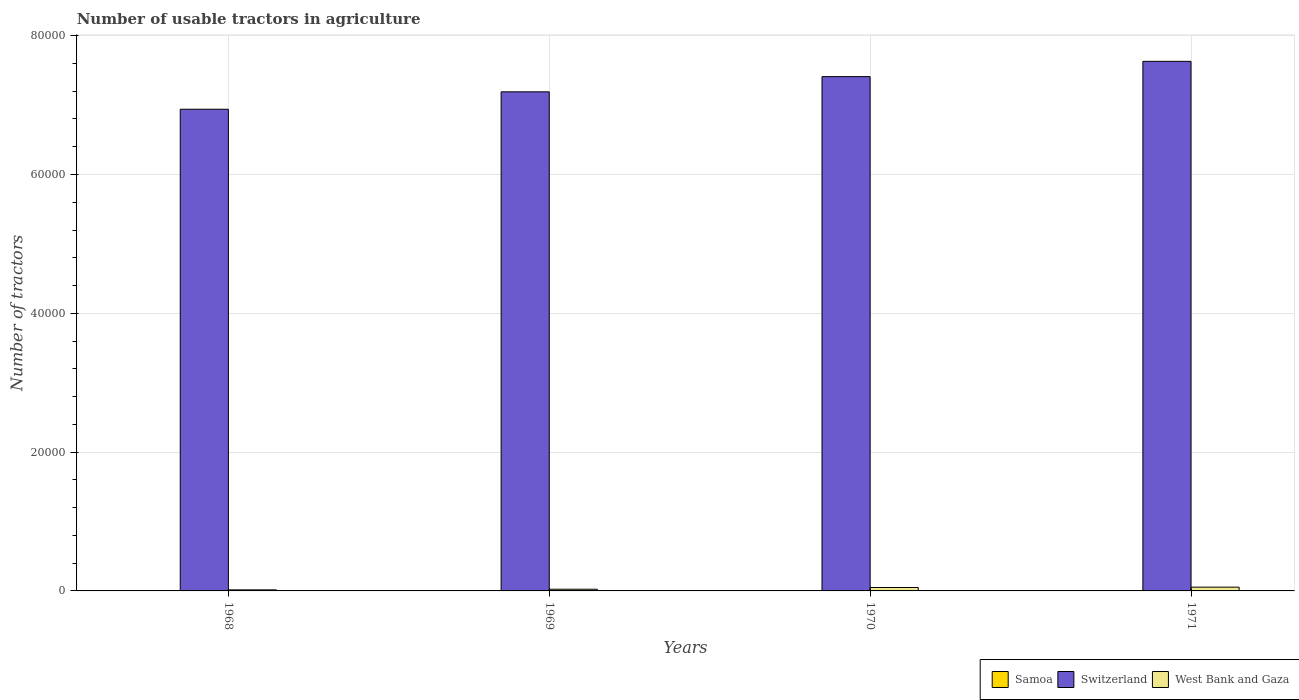How many different coloured bars are there?
Give a very brief answer. 3. How many groups of bars are there?
Offer a terse response. 4. How many bars are there on the 1st tick from the left?
Give a very brief answer. 3. In how many cases, is the number of bars for a given year not equal to the number of legend labels?
Your answer should be very brief. 0. What is the number of usable tractors in agriculture in Switzerland in 1968?
Give a very brief answer. 6.94e+04. Across all years, what is the maximum number of usable tractors in agriculture in Switzerland?
Your response must be concise. 7.63e+04. Across all years, what is the minimum number of usable tractors in agriculture in West Bank and Gaza?
Keep it short and to the point. 152. In which year was the number of usable tractors in agriculture in Switzerland maximum?
Your answer should be compact. 1971. In which year was the number of usable tractors in agriculture in Switzerland minimum?
Your answer should be compact. 1968. What is the total number of usable tractors in agriculture in Samoa in the graph?
Make the answer very short. 64. What is the difference between the number of usable tractors in agriculture in West Bank and Gaza in 1970 and that in 1971?
Provide a succinct answer. -53. What is the difference between the number of usable tractors in agriculture in Switzerland in 1968 and the number of usable tractors in agriculture in Samoa in 1971?
Offer a terse response. 6.94e+04. In the year 1970, what is the difference between the number of usable tractors in agriculture in West Bank and Gaza and number of usable tractors in agriculture in Samoa?
Make the answer very short. 476. In how many years, is the number of usable tractors in agriculture in Samoa greater than 40000?
Provide a short and direct response. 0. What is the ratio of the number of usable tractors in agriculture in Switzerland in 1970 to that in 1971?
Give a very brief answer. 0.97. What is the difference between the highest and the second highest number of usable tractors in agriculture in West Bank and Gaza?
Your answer should be very brief. 53. What does the 1st bar from the left in 1968 represents?
Give a very brief answer. Samoa. What does the 2nd bar from the right in 1971 represents?
Give a very brief answer. Switzerland. Is it the case that in every year, the sum of the number of usable tractors in agriculture in Samoa and number of usable tractors in agriculture in Switzerland is greater than the number of usable tractors in agriculture in West Bank and Gaza?
Your answer should be very brief. Yes. How many bars are there?
Give a very brief answer. 12. How many years are there in the graph?
Provide a short and direct response. 4. Does the graph contain grids?
Provide a short and direct response. Yes. Where does the legend appear in the graph?
Offer a terse response. Bottom right. How many legend labels are there?
Offer a terse response. 3. What is the title of the graph?
Make the answer very short. Number of usable tractors in agriculture. Does "Panama" appear as one of the legend labels in the graph?
Provide a succinct answer. No. What is the label or title of the Y-axis?
Give a very brief answer. Number of tractors. What is the Number of tractors of Switzerland in 1968?
Your answer should be compact. 6.94e+04. What is the Number of tractors in West Bank and Gaza in 1968?
Offer a terse response. 152. What is the Number of tractors of Switzerland in 1969?
Your answer should be compact. 7.19e+04. What is the Number of tractors in West Bank and Gaza in 1969?
Give a very brief answer. 244. What is the Number of tractors of Samoa in 1970?
Offer a very short reply. 15. What is the Number of tractors in Switzerland in 1970?
Your answer should be very brief. 7.41e+04. What is the Number of tractors in West Bank and Gaza in 1970?
Offer a very short reply. 491. What is the Number of tractors in Switzerland in 1971?
Ensure brevity in your answer.  7.63e+04. What is the Number of tractors in West Bank and Gaza in 1971?
Keep it short and to the point. 544. Across all years, what is the maximum Number of tractors of Samoa?
Offer a very short reply. 18. Across all years, what is the maximum Number of tractors of Switzerland?
Offer a very short reply. 7.63e+04. Across all years, what is the maximum Number of tractors in West Bank and Gaza?
Provide a succinct answer. 544. Across all years, what is the minimum Number of tractors in Switzerland?
Offer a terse response. 6.94e+04. Across all years, what is the minimum Number of tractors of West Bank and Gaza?
Your answer should be very brief. 152. What is the total Number of tractors of Switzerland in the graph?
Make the answer very short. 2.92e+05. What is the total Number of tractors in West Bank and Gaza in the graph?
Provide a succinct answer. 1431. What is the difference between the Number of tractors of Samoa in 1968 and that in 1969?
Ensure brevity in your answer.  1. What is the difference between the Number of tractors of Switzerland in 1968 and that in 1969?
Your answer should be compact. -2509. What is the difference between the Number of tractors of West Bank and Gaza in 1968 and that in 1969?
Provide a succinct answer. -92. What is the difference between the Number of tractors of Samoa in 1968 and that in 1970?
Your response must be concise. 1. What is the difference between the Number of tractors in Switzerland in 1968 and that in 1970?
Your answer should be compact. -4700. What is the difference between the Number of tractors of West Bank and Gaza in 1968 and that in 1970?
Offer a very short reply. -339. What is the difference between the Number of tractors in Switzerland in 1968 and that in 1971?
Provide a short and direct response. -6900. What is the difference between the Number of tractors of West Bank and Gaza in 1968 and that in 1971?
Make the answer very short. -392. What is the difference between the Number of tractors of Switzerland in 1969 and that in 1970?
Ensure brevity in your answer.  -2191. What is the difference between the Number of tractors in West Bank and Gaza in 1969 and that in 1970?
Your response must be concise. -247. What is the difference between the Number of tractors of Samoa in 1969 and that in 1971?
Your answer should be very brief. -3. What is the difference between the Number of tractors of Switzerland in 1969 and that in 1971?
Offer a terse response. -4391. What is the difference between the Number of tractors of West Bank and Gaza in 1969 and that in 1971?
Your response must be concise. -300. What is the difference between the Number of tractors of Switzerland in 1970 and that in 1971?
Provide a short and direct response. -2200. What is the difference between the Number of tractors of West Bank and Gaza in 1970 and that in 1971?
Keep it short and to the point. -53. What is the difference between the Number of tractors in Samoa in 1968 and the Number of tractors in Switzerland in 1969?
Keep it short and to the point. -7.19e+04. What is the difference between the Number of tractors in Samoa in 1968 and the Number of tractors in West Bank and Gaza in 1969?
Offer a very short reply. -228. What is the difference between the Number of tractors of Switzerland in 1968 and the Number of tractors of West Bank and Gaza in 1969?
Keep it short and to the point. 6.92e+04. What is the difference between the Number of tractors of Samoa in 1968 and the Number of tractors of Switzerland in 1970?
Offer a very short reply. -7.41e+04. What is the difference between the Number of tractors in Samoa in 1968 and the Number of tractors in West Bank and Gaza in 1970?
Provide a short and direct response. -475. What is the difference between the Number of tractors in Switzerland in 1968 and the Number of tractors in West Bank and Gaza in 1970?
Provide a succinct answer. 6.89e+04. What is the difference between the Number of tractors in Samoa in 1968 and the Number of tractors in Switzerland in 1971?
Keep it short and to the point. -7.63e+04. What is the difference between the Number of tractors in Samoa in 1968 and the Number of tractors in West Bank and Gaza in 1971?
Your response must be concise. -528. What is the difference between the Number of tractors of Switzerland in 1968 and the Number of tractors of West Bank and Gaza in 1971?
Your answer should be compact. 6.89e+04. What is the difference between the Number of tractors of Samoa in 1969 and the Number of tractors of Switzerland in 1970?
Keep it short and to the point. -7.41e+04. What is the difference between the Number of tractors of Samoa in 1969 and the Number of tractors of West Bank and Gaza in 1970?
Ensure brevity in your answer.  -476. What is the difference between the Number of tractors in Switzerland in 1969 and the Number of tractors in West Bank and Gaza in 1970?
Your answer should be compact. 7.14e+04. What is the difference between the Number of tractors in Samoa in 1969 and the Number of tractors in Switzerland in 1971?
Provide a short and direct response. -7.63e+04. What is the difference between the Number of tractors in Samoa in 1969 and the Number of tractors in West Bank and Gaza in 1971?
Your answer should be compact. -529. What is the difference between the Number of tractors in Switzerland in 1969 and the Number of tractors in West Bank and Gaza in 1971?
Offer a terse response. 7.14e+04. What is the difference between the Number of tractors in Samoa in 1970 and the Number of tractors in Switzerland in 1971?
Offer a terse response. -7.63e+04. What is the difference between the Number of tractors in Samoa in 1970 and the Number of tractors in West Bank and Gaza in 1971?
Provide a short and direct response. -529. What is the difference between the Number of tractors in Switzerland in 1970 and the Number of tractors in West Bank and Gaza in 1971?
Your answer should be compact. 7.36e+04. What is the average Number of tractors of Samoa per year?
Your answer should be very brief. 16. What is the average Number of tractors in Switzerland per year?
Offer a terse response. 7.29e+04. What is the average Number of tractors in West Bank and Gaza per year?
Keep it short and to the point. 357.75. In the year 1968, what is the difference between the Number of tractors in Samoa and Number of tractors in Switzerland?
Keep it short and to the point. -6.94e+04. In the year 1968, what is the difference between the Number of tractors in Samoa and Number of tractors in West Bank and Gaza?
Provide a short and direct response. -136. In the year 1968, what is the difference between the Number of tractors of Switzerland and Number of tractors of West Bank and Gaza?
Your answer should be compact. 6.92e+04. In the year 1969, what is the difference between the Number of tractors in Samoa and Number of tractors in Switzerland?
Your answer should be compact. -7.19e+04. In the year 1969, what is the difference between the Number of tractors of Samoa and Number of tractors of West Bank and Gaza?
Give a very brief answer. -229. In the year 1969, what is the difference between the Number of tractors of Switzerland and Number of tractors of West Bank and Gaza?
Ensure brevity in your answer.  7.17e+04. In the year 1970, what is the difference between the Number of tractors of Samoa and Number of tractors of Switzerland?
Your answer should be compact. -7.41e+04. In the year 1970, what is the difference between the Number of tractors in Samoa and Number of tractors in West Bank and Gaza?
Your answer should be very brief. -476. In the year 1970, what is the difference between the Number of tractors of Switzerland and Number of tractors of West Bank and Gaza?
Give a very brief answer. 7.36e+04. In the year 1971, what is the difference between the Number of tractors in Samoa and Number of tractors in Switzerland?
Provide a succinct answer. -7.63e+04. In the year 1971, what is the difference between the Number of tractors in Samoa and Number of tractors in West Bank and Gaza?
Your answer should be compact. -526. In the year 1971, what is the difference between the Number of tractors in Switzerland and Number of tractors in West Bank and Gaza?
Make the answer very short. 7.58e+04. What is the ratio of the Number of tractors of Samoa in 1968 to that in 1969?
Offer a very short reply. 1.07. What is the ratio of the Number of tractors in Switzerland in 1968 to that in 1969?
Your answer should be very brief. 0.97. What is the ratio of the Number of tractors in West Bank and Gaza in 1968 to that in 1969?
Provide a short and direct response. 0.62. What is the ratio of the Number of tractors in Samoa in 1968 to that in 1970?
Offer a terse response. 1.07. What is the ratio of the Number of tractors in Switzerland in 1968 to that in 1970?
Ensure brevity in your answer.  0.94. What is the ratio of the Number of tractors of West Bank and Gaza in 1968 to that in 1970?
Provide a succinct answer. 0.31. What is the ratio of the Number of tractors of Switzerland in 1968 to that in 1971?
Provide a short and direct response. 0.91. What is the ratio of the Number of tractors in West Bank and Gaza in 1968 to that in 1971?
Your answer should be compact. 0.28. What is the ratio of the Number of tractors in Samoa in 1969 to that in 1970?
Keep it short and to the point. 1. What is the ratio of the Number of tractors of Switzerland in 1969 to that in 1970?
Offer a terse response. 0.97. What is the ratio of the Number of tractors of West Bank and Gaza in 1969 to that in 1970?
Provide a succinct answer. 0.5. What is the ratio of the Number of tractors in Switzerland in 1969 to that in 1971?
Offer a very short reply. 0.94. What is the ratio of the Number of tractors of West Bank and Gaza in 1969 to that in 1971?
Your response must be concise. 0.45. What is the ratio of the Number of tractors in Switzerland in 1970 to that in 1971?
Give a very brief answer. 0.97. What is the ratio of the Number of tractors of West Bank and Gaza in 1970 to that in 1971?
Give a very brief answer. 0.9. What is the difference between the highest and the second highest Number of tractors of Switzerland?
Your response must be concise. 2200. What is the difference between the highest and the lowest Number of tractors of Switzerland?
Keep it short and to the point. 6900. What is the difference between the highest and the lowest Number of tractors in West Bank and Gaza?
Keep it short and to the point. 392. 